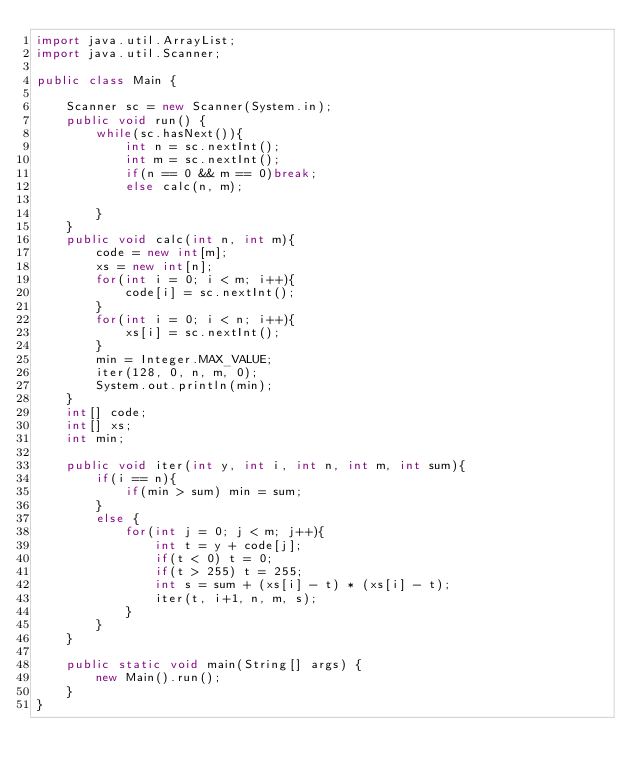<code> <loc_0><loc_0><loc_500><loc_500><_Java_>import java.util.ArrayList;
import java.util.Scanner;

public class Main {

	Scanner sc = new Scanner(System.in);
	public void run() {
		while(sc.hasNext()){
			int n = sc.nextInt();
			int m = sc.nextInt();
			if(n == 0 && m == 0)break;
			else calc(n, m);
			
		}
	}
	public void calc(int n, int m){
		code = new int[m];
		xs = new int[n];
		for(int i = 0; i < m; i++){
			code[i] = sc.nextInt();
		}
		for(int i = 0; i < n; i++){
			xs[i] = sc.nextInt();
		}
		min = Integer.MAX_VALUE;
		iter(128, 0, n, m, 0);
		System.out.println(min);
	}
	int[] code;
	int[] xs;
	int min;

	public void iter(int y, int i, int n, int m, int sum){
		if(i == n){
			if(min > sum) min = sum;
		}
		else {
			for(int j = 0; j < m; j++){
				int t = y + code[j];
				if(t < 0) t = 0;
				if(t > 255) t = 255;
				int s = sum + (xs[i] - t) * (xs[i] - t);
				iter(t, i+1, n, m, s);
			}
		}
	}
	
	public static void main(String[] args) {
		new Main().run();
	}
}</code> 